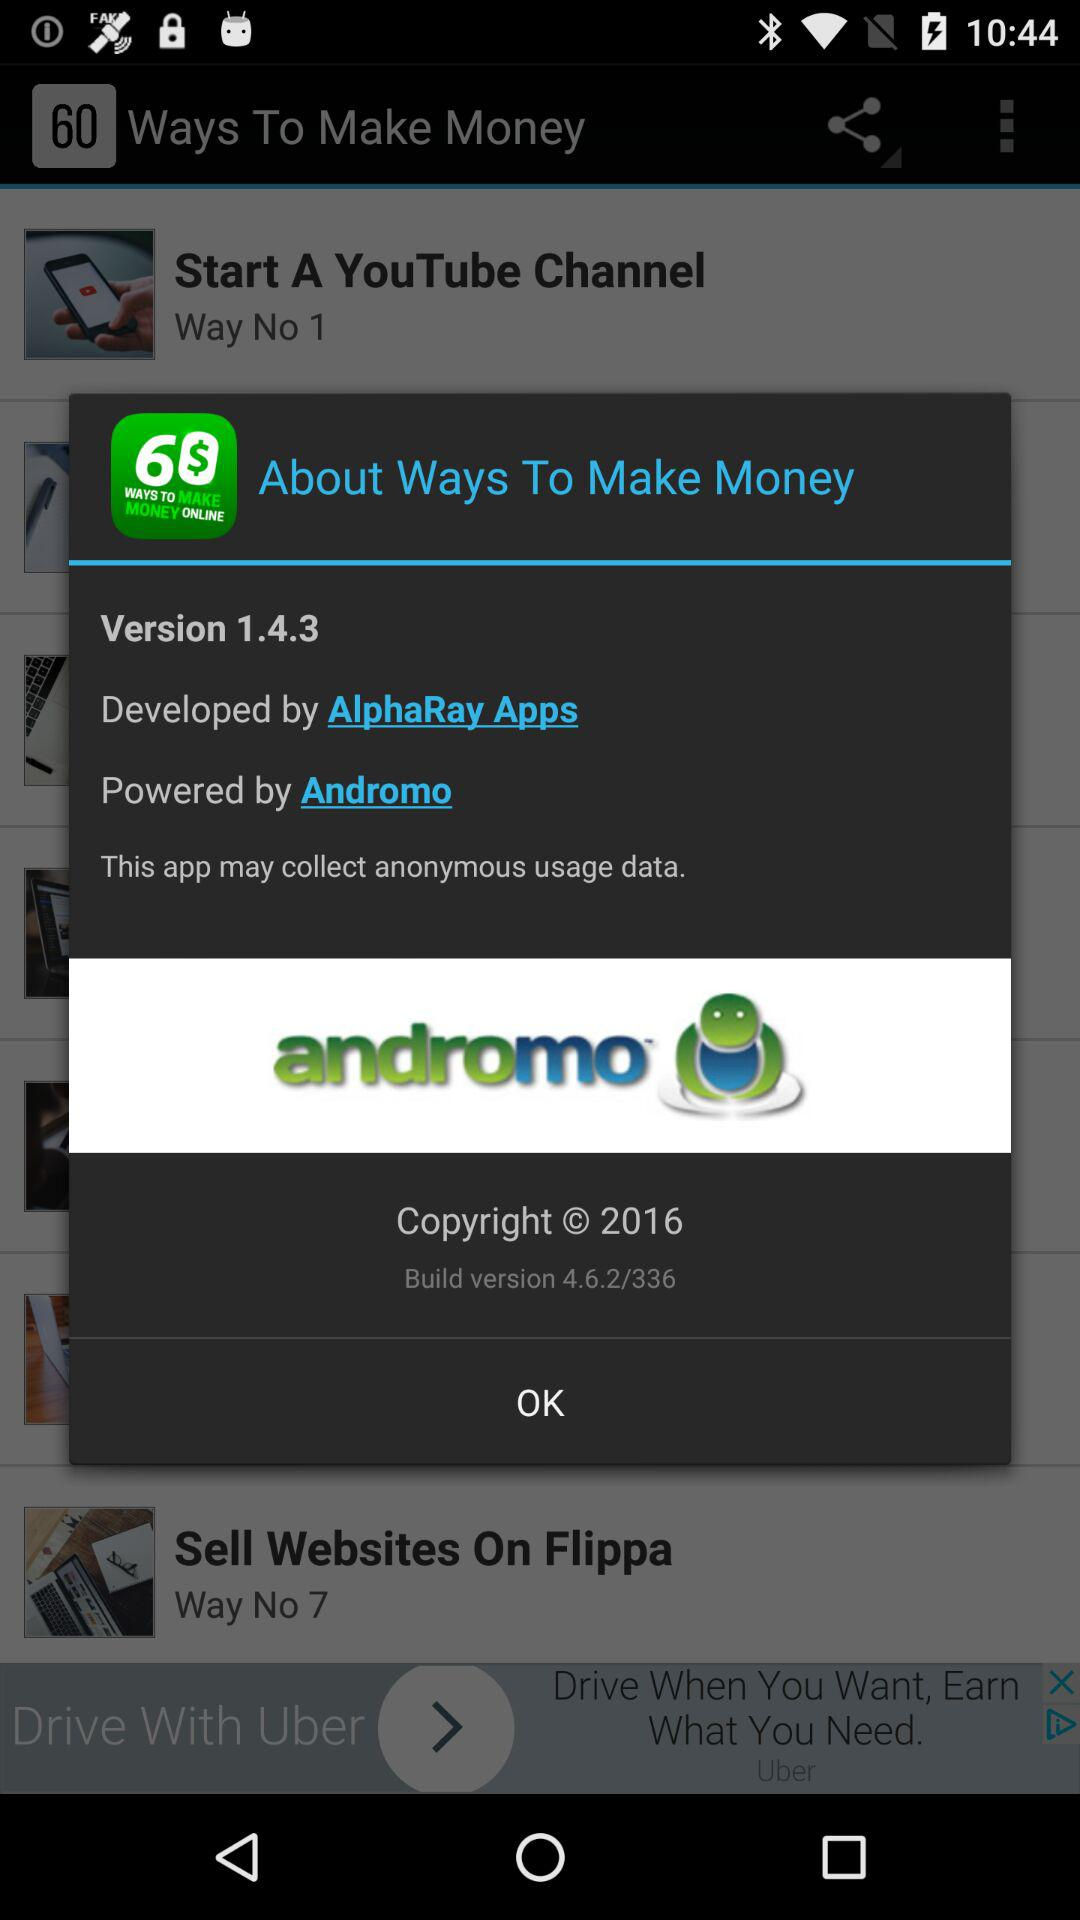Which version is this? The version is 1.4.3. 